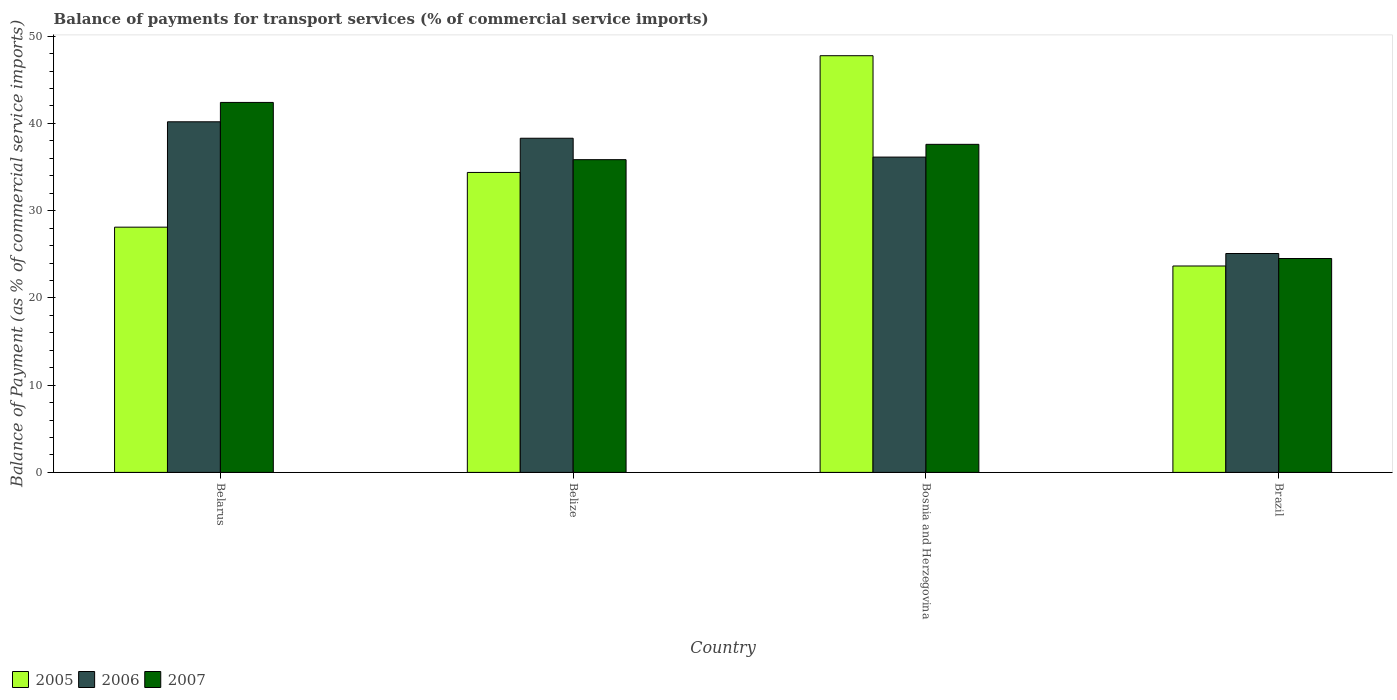How many different coloured bars are there?
Your response must be concise. 3. Are the number of bars per tick equal to the number of legend labels?
Offer a terse response. Yes. Are the number of bars on each tick of the X-axis equal?
Make the answer very short. Yes. How many bars are there on the 1st tick from the right?
Your response must be concise. 3. In how many cases, is the number of bars for a given country not equal to the number of legend labels?
Provide a succinct answer. 0. What is the balance of payments for transport services in 2005 in Belarus?
Your answer should be very brief. 28.11. Across all countries, what is the maximum balance of payments for transport services in 2005?
Give a very brief answer. 47.76. Across all countries, what is the minimum balance of payments for transport services in 2006?
Provide a short and direct response. 25.09. In which country was the balance of payments for transport services in 2006 maximum?
Make the answer very short. Belarus. What is the total balance of payments for transport services in 2007 in the graph?
Make the answer very short. 140.38. What is the difference between the balance of payments for transport services in 2007 in Belarus and that in Bosnia and Herzegovina?
Provide a short and direct response. 4.8. What is the difference between the balance of payments for transport services in 2005 in Belize and the balance of payments for transport services in 2006 in Belarus?
Offer a very short reply. -5.81. What is the average balance of payments for transport services in 2006 per country?
Make the answer very short. 34.93. What is the difference between the balance of payments for transport services of/in 2006 and balance of payments for transport services of/in 2007 in Bosnia and Herzegovina?
Provide a short and direct response. -1.46. In how many countries, is the balance of payments for transport services in 2006 greater than 6 %?
Offer a very short reply. 4. What is the ratio of the balance of payments for transport services in 2006 in Belarus to that in Brazil?
Offer a terse response. 1.6. Is the balance of payments for transport services in 2005 in Bosnia and Herzegovina less than that in Brazil?
Ensure brevity in your answer.  No. Is the difference between the balance of payments for transport services in 2006 in Bosnia and Herzegovina and Brazil greater than the difference between the balance of payments for transport services in 2007 in Bosnia and Herzegovina and Brazil?
Your answer should be very brief. No. What is the difference between the highest and the second highest balance of payments for transport services in 2007?
Your response must be concise. 6.56. What is the difference between the highest and the lowest balance of payments for transport services in 2007?
Offer a terse response. 17.89. Is the sum of the balance of payments for transport services in 2007 in Bosnia and Herzegovina and Brazil greater than the maximum balance of payments for transport services in 2006 across all countries?
Offer a terse response. Yes. What does the 3rd bar from the right in Bosnia and Herzegovina represents?
Make the answer very short. 2005. Is it the case that in every country, the sum of the balance of payments for transport services in 2006 and balance of payments for transport services in 2005 is greater than the balance of payments for transport services in 2007?
Make the answer very short. Yes. Are all the bars in the graph horizontal?
Your response must be concise. No. How many countries are there in the graph?
Make the answer very short. 4. Does the graph contain grids?
Ensure brevity in your answer.  No. How many legend labels are there?
Offer a terse response. 3. What is the title of the graph?
Your answer should be very brief. Balance of payments for transport services (% of commercial service imports). Does "1961" appear as one of the legend labels in the graph?
Your response must be concise. No. What is the label or title of the Y-axis?
Provide a short and direct response. Balance of Payment (as % of commercial service imports). What is the Balance of Payment (as % of commercial service imports) in 2005 in Belarus?
Your answer should be compact. 28.11. What is the Balance of Payment (as % of commercial service imports) in 2006 in Belarus?
Give a very brief answer. 40.19. What is the Balance of Payment (as % of commercial service imports) in 2007 in Belarus?
Keep it short and to the point. 42.41. What is the Balance of Payment (as % of commercial service imports) in 2005 in Belize?
Your answer should be compact. 34.38. What is the Balance of Payment (as % of commercial service imports) in 2006 in Belize?
Your answer should be compact. 38.3. What is the Balance of Payment (as % of commercial service imports) in 2007 in Belize?
Offer a very short reply. 35.85. What is the Balance of Payment (as % of commercial service imports) of 2005 in Bosnia and Herzegovina?
Keep it short and to the point. 47.76. What is the Balance of Payment (as % of commercial service imports) of 2006 in Bosnia and Herzegovina?
Your answer should be compact. 36.14. What is the Balance of Payment (as % of commercial service imports) of 2007 in Bosnia and Herzegovina?
Provide a succinct answer. 37.6. What is the Balance of Payment (as % of commercial service imports) in 2005 in Brazil?
Make the answer very short. 23.66. What is the Balance of Payment (as % of commercial service imports) in 2006 in Brazil?
Your answer should be compact. 25.09. What is the Balance of Payment (as % of commercial service imports) of 2007 in Brazil?
Your answer should be compact. 24.52. Across all countries, what is the maximum Balance of Payment (as % of commercial service imports) in 2005?
Your response must be concise. 47.76. Across all countries, what is the maximum Balance of Payment (as % of commercial service imports) of 2006?
Provide a short and direct response. 40.19. Across all countries, what is the maximum Balance of Payment (as % of commercial service imports) of 2007?
Provide a succinct answer. 42.41. Across all countries, what is the minimum Balance of Payment (as % of commercial service imports) in 2005?
Make the answer very short. 23.66. Across all countries, what is the minimum Balance of Payment (as % of commercial service imports) of 2006?
Provide a short and direct response. 25.09. Across all countries, what is the minimum Balance of Payment (as % of commercial service imports) of 2007?
Your answer should be compact. 24.52. What is the total Balance of Payment (as % of commercial service imports) of 2005 in the graph?
Provide a succinct answer. 133.92. What is the total Balance of Payment (as % of commercial service imports) in 2006 in the graph?
Your response must be concise. 139.72. What is the total Balance of Payment (as % of commercial service imports) in 2007 in the graph?
Offer a terse response. 140.38. What is the difference between the Balance of Payment (as % of commercial service imports) of 2005 in Belarus and that in Belize?
Your answer should be compact. -6.27. What is the difference between the Balance of Payment (as % of commercial service imports) in 2006 in Belarus and that in Belize?
Make the answer very short. 1.89. What is the difference between the Balance of Payment (as % of commercial service imports) in 2007 in Belarus and that in Belize?
Provide a succinct answer. 6.56. What is the difference between the Balance of Payment (as % of commercial service imports) in 2005 in Belarus and that in Bosnia and Herzegovina?
Provide a succinct answer. -19.65. What is the difference between the Balance of Payment (as % of commercial service imports) of 2006 in Belarus and that in Bosnia and Herzegovina?
Give a very brief answer. 4.04. What is the difference between the Balance of Payment (as % of commercial service imports) in 2007 in Belarus and that in Bosnia and Herzegovina?
Ensure brevity in your answer.  4.8. What is the difference between the Balance of Payment (as % of commercial service imports) of 2005 in Belarus and that in Brazil?
Your response must be concise. 4.45. What is the difference between the Balance of Payment (as % of commercial service imports) of 2006 in Belarus and that in Brazil?
Offer a terse response. 15.1. What is the difference between the Balance of Payment (as % of commercial service imports) of 2007 in Belarus and that in Brazil?
Your answer should be compact. 17.89. What is the difference between the Balance of Payment (as % of commercial service imports) in 2005 in Belize and that in Bosnia and Herzegovina?
Ensure brevity in your answer.  -13.38. What is the difference between the Balance of Payment (as % of commercial service imports) in 2006 in Belize and that in Bosnia and Herzegovina?
Keep it short and to the point. 2.16. What is the difference between the Balance of Payment (as % of commercial service imports) of 2007 in Belize and that in Bosnia and Herzegovina?
Your answer should be very brief. -1.76. What is the difference between the Balance of Payment (as % of commercial service imports) of 2005 in Belize and that in Brazil?
Provide a short and direct response. 10.72. What is the difference between the Balance of Payment (as % of commercial service imports) in 2006 in Belize and that in Brazil?
Provide a succinct answer. 13.21. What is the difference between the Balance of Payment (as % of commercial service imports) of 2007 in Belize and that in Brazil?
Your answer should be very brief. 11.33. What is the difference between the Balance of Payment (as % of commercial service imports) of 2005 in Bosnia and Herzegovina and that in Brazil?
Keep it short and to the point. 24.1. What is the difference between the Balance of Payment (as % of commercial service imports) of 2006 in Bosnia and Herzegovina and that in Brazil?
Ensure brevity in your answer.  11.05. What is the difference between the Balance of Payment (as % of commercial service imports) of 2007 in Bosnia and Herzegovina and that in Brazil?
Offer a terse response. 13.09. What is the difference between the Balance of Payment (as % of commercial service imports) in 2005 in Belarus and the Balance of Payment (as % of commercial service imports) in 2006 in Belize?
Keep it short and to the point. -10.19. What is the difference between the Balance of Payment (as % of commercial service imports) of 2005 in Belarus and the Balance of Payment (as % of commercial service imports) of 2007 in Belize?
Your answer should be very brief. -7.74. What is the difference between the Balance of Payment (as % of commercial service imports) in 2006 in Belarus and the Balance of Payment (as % of commercial service imports) in 2007 in Belize?
Provide a succinct answer. 4.34. What is the difference between the Balance of Payment (as % of commercial service imports) of 2005 in Belarus and the Balance of Payment (as % of commercial service imports) of 2006 in Bosnia and Herzegovina?
Ensure brevity in your answer.  -8.03. What is the difference between the Balance of Payment (as % of commercial service imports) in 2005 in Belarus and the Balance of Payment (as % of commercial service imports) in 2007 in Bosnia and Herzegovina?
Give a very brief answer. -9.49. What is the difference between the Balance of Payment (as % of commercial service imports) of 2006 in Belarus and the Balance of Payment (as % of commercial service imports) of 2007 in Bosnia and Herzegovina?
Offer a terse response. 2.58. What is the difference between the Balance of Payment (as % of commercial service imports) of 2005 in Belarus and the Balance of Payment (as % of commercial service imports) of 2006 in Brazil?
Offer a very short reply. 3.02. What is the difference between the Balance of Payment (as % of commercial service imports) of 2005 in Belarus and the Balance of Payment (as % of commercial service imports) of 2007 in Brazil?
Provide a short and direct response. 3.59. What is the difference between the Balance of Payment (as % of commercial service imports) in 2006 in Belarus and the Balance of Payment (as % of commercial service imports) in 2007 in Brazil?
Provide a short and direct response. 15.67. What is the difference between the Balance of Payment (as % of commercial service imports) of 2005 in Belize and the Balance of Payment (as % of commercial service imports) of 2006 in Bosnia and Herzegovina?
Keep it short and to the point. -1.76. What is the difference between the Balance of Payment (as % of commercial service imports) in 2005 in Belize and the Balance of Payment (as % of commercial service imports) in 2007 in Bosnia and Herzegovina?
Make the answer very short. -3.22. What is the difference between the Balance of Payment (as % of commercial service imports) in 2006 in Belize and the Balance of Payment (as % of commercial service imports) in 2007 in Bosnia and Herzegovina?
Offer a terse response. 0.7. What is the difference between the Balance of Payment (as % of commercial service imports) of 2005 in Belize and the Balance of Payment (as % of commercial service imports) of 2006 in Brazil?
Ensure brevity in your answer.  9.29. What is the difference between the Balance of Payment (as % of commercial service imports) in 2005 in Belize and the Balance of Payment (as % of commercial service imports) in 2007 in Brazil?
Make the answer very short. 9.87. What is the difference between the Balance of Payment (as % of commercial service imports) in 2006 in Belize and the Balance of Payment (as % of commercial service imports) in 2007 in Brazil?
Your response must be concise. 13.79. What is the difference between the Balance of Payment (as % of commercial service imports) in 2005 in Bosnia and Herzegovina and the Balance of Payment (as % of commercial service imports) in 2006 in Brazil?
Offer a terse response. 22.67. What is the difference between the Balance of Payment (as % of commercial service imports) of 2005 in Bosnia and Herzegovina and the Balance of Payment (as % of commercial service imports) of 2007 in Brazil?
Give a very brief answer. 23.25. What is the difference between the Balance of Payment (as % of commercial service imports) of 2006 in Bosnia and Herzegovina and the Balance of Payment (as % of commercial service imports) of 2007 in Brazil?
Your response must be concise. 11.63. What is the average Balance of Payment (as % of commercial service imports) of 2005 per country?
Offer a terse response. 33.48. What is the average Balance of Payment (as % of commercial service imports) in 2006 per country?
Ensure brevity in your answer.  34.93. What is the average Balance of Payment (as % of commercial service imports) in 2007 per country?
Provide a succinct answer. 35.09. What is the difference between the Balance of Payment (as % of commercial service imports) of 2005 and Balance of Payment (as % of commercial service imports) of 2006 in Belarus?
Offer a terse response. -12.08. What is the difference between the Balance of Payment (as % of commercial service imports) of 2005 and Balance of Payment (as % of commercial service imports) of 2007 in Belarus?
Provide a short and direct response. -14.3. What is the difference between the Balance of Payment (as % of commercial service imports) of 2006 and Balance of Payment (as % of commercial service imports) of 2007 in Belarus?
Offer a very short reply. -2.22. What is the difference between the Balance of Payment (as % of commercial service imports) of 2005 and Balance of Payment (as % of commercial service imports) of 2006 in Belize?
Make the answer very short. -3.92. What is the difference between the Balance of Payment (as % of commercial service imports) in 2005 and Balance of Payment (as % of commercial service imports) in 2007 in Belize?
Make the answer very short. -1.46. What is the difference between the Balance of Payment (as % of commercial service imports) of 2006 and Balance of Payment (as % of commercial service imports) of 2007 in Belize?
Offer a very short reply. 2.46. What is the difference between the Balance of Payment (as % of commercial service imports) in 2005 and Balance of Payment (as % of commercial service imports) in 2006 in Bosnia and Herzegovina?
Offer a very short reply. 11.62. What is the difference between the Balance of Payment (as % of commercial service imports) of 2005 and Balance of Payment (as % of commercial service imports) of 2007 in Bosnia and Herzegovina?
Ensure brevity in your answer.  10.16. What is the difference between the Balance of Payment (as % of commercial service imports) in 2006 and Balance of Payment (as % of commercial service imports) in 2007 in Bosnia and Herzegovina?
Provide a succinct answer. -1.46. What is the difference between the Balance of Payment (as % of commercial service imports) of 2005 and Balance of Payment (as % of commercial service imports) of 2006 in Brazil?
Your answer should be compact. -1.43. What is the difference between the Balance of Payment (as % of commercial service imports) of 2005 and Balance of Payment (as % of commercial service imports) of 2007 in Brazil?
Provide a short and direct response. -0.86. What is the difference between the Balance of Payment (as % of commercial service imports) in 2006 and Balance of Payment (as % of commercial service imports) in 2007 in Brazil?
Your answer should be very brief. 0.57. What is the ratio of the Balance of Payment (as % of commercial service imports) of 2005 in Belarus to that in Belize?
Offer a terse response. 0.82. What is the ratio of the Balance of Payment (as % of commercial service imports) in 2006 in Belarus to that in Belize?
Keep it short and to the point. 1.05. What is the ratio of the Balance of Payment (as % of commercial service imports) of 2007 in Belarus to that in Belize?
Provide a succinct answer. 1.18. What is the ratio of the Balance of Payment (as % of commercial service imports) in 2005 in Belarus to that in Bosnia and Herzegovina?
Ensure brevity in your answer.  0.59. What is the ratio of the Balance of Payment (as % of commercial service imports) in 2006 in Belarus to that in Bosnia and Herzegovina?
Offer a terse response. 1.11. What is the ratio of the Balance of Payment (as % of commercial service imports) of 2007 in Belarus to that in Bosnia and Herzegovina?
Give a very brief answer. 1.13. What is the ratio of the Balance of Payment (as % of commercial service imports) in 2005 in Belarus to that in Brazil?
Your response must be concise. 1.19. What is the ratio of the Balance of Payment (as % of commercial service imports) of 2006 in Belarus to that in Brazil?
Provide a short and direct response. 1.6. What is the ratio of the Balance of Payment (as % of commercial service imports) in 2007 in Belarus to that in Brazil?
Provide a succinct answer. 1.73. What is the ratio of the Balance of Payment (as % of commercial service imports) in 2005 in Belize to that in Bosnia and Herzegovina?
Your answer should be very brief. 0.72. What is the ratio of the Balance of Payment (as % of commercial service imports) of 2006 in Belize to that in Bosnia and Herzegovina?
Provide a succinct answer. 1.06. What is the ratio of the Balance of Payment (as % of commercial service imports) in 2007 in Belize to that in Bosnia and Herzegovina?
Offer a terse response. 0.95. What is the ratio of the Balance of Payment (as % of commercial service imports) in 2005 in Belize to that in Brazil?
Your answer should be compact. 1.45. What is the ratio of the Balance of Payment (as % of commercial service imports) in 2006 in Belize to that in Brazil?
Give a very brief answer. 1.53. What is the ratio of the Balance of Payment (as % of commercial service imports) of 2007 in Belize to that in Brazil?
Provide a short and direct response. 1.46. What is the ratio of the Balance of Payment (as % of commercial service imports) in 2005 in Bosnia and Herzegovina to that in Brazil?
Your response must be concise. 2.02. What is the ratio of the Balance of Payment (as % of commercial service imports) of 2006 in Bosnia and Herzegovina to that in Brazil?
Provide a short and direct response. 1.44. What is the ratio of the Balance of Payment (as % of commercial service imports) of 2007 in Bosnia and Herzegovina to that in Brazil?
Provide a succinct answer. 1.53. What is the difference between the highest and the second highest Balance of Payment (as % of commercial service imports) in 2005?
Provide a short and direct response. 13.38. What is the difference between the highest and the second highest Balance of Payment (as % of commercial service imports) in 2006?
Provide a short and direct response. 1.89. What is the difference between the highest and the second highest Balance of Payment (as % of commercial service imports) of 2007?
Give a very brief answer. 4.8. What is the difference between the highest and the lowest Balance of Payment (as % of commercial service imports) in 2005?
Your answer should be compact. 24.1. What is the difference between the highest and the lowest Balance of Payment (as % of commercial service imports) in 2006?
Make the answer very short. 15.1. What is the difference between the highest and the lowest Balance of Payment (as % of commercial service imports) of 2007?
Keep it short and to the point. 17.89. 